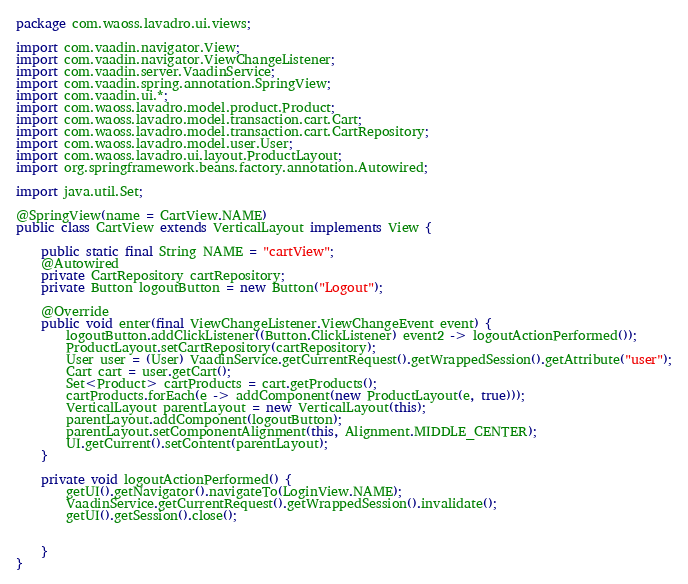Convert code to text. <code><loc_0><loc_0><loc_500><loc_500><_Java_>package com.waoss.lavadro.ui.views;

import com.vaadin.navigator.View;
import com.vaadin.navigator.ViewChangeListener;
import com.vaadin.server.VaadinService;
import com.vaadin.spring.annotation.SpringView;
import com.vaadin.ui.*;
import com.waoss.lavadro.model.product.Product;
import com.waoss.lavadro.model.transaction.cart.Cart;
import com.waoss.lavadro.model.transaction.cart.CartRepository;
import com.waoss.lavadro.model.user.User;
import com.waoss.lavadro.ui.layout.ProductLayout;
import org.springframework.beans.factory.annotation.Autowired;

import java.util.Set;

@SpringView(name = CartView.NAME)
public class CartView extends VerticalLayout implements View {

    public static final String NAME = "cartView";
    @Autowired
    private CartRepository cartRepository;
    private Button logoutButton = new Button("Logout");

    @Override
    public void enter(final ViewChangeListener.ViewChangeEvent event) {
        logoutButton.addClickListener((Button.ClickListener) event2 -> logoutActionPerformed());
        ProductLayout.setCartRepository(cartRepository);
        User user = (User) VaadinService.getCurrentRequest().getWrappedSession().getAttribute("user");
        Cart cart = user.getCart();
        Set<Product> cartProducts = cart.getProducts();
        cartProducts.forEach(e -> addComponent(new ProductLayout(e, true)));
        VerticalLayout parentLayout = new VerticalLayout(this);
        parentLayout.addComponent(logoutButton);
        parentLayout.setComponentAlignment(this, Alignment.MIDDLE_CENTER);
        UI.getCurrent().setContent(parentLayout);
    }

    private void logoutActionPerformed() {
        getUI().getNavigator().navigateTo(LoginView.NAME);
        VaadinService.getCurrentRequest().getWrappedSession().invalidate();
        getUI().getSession().close();


    }
}
</code> 